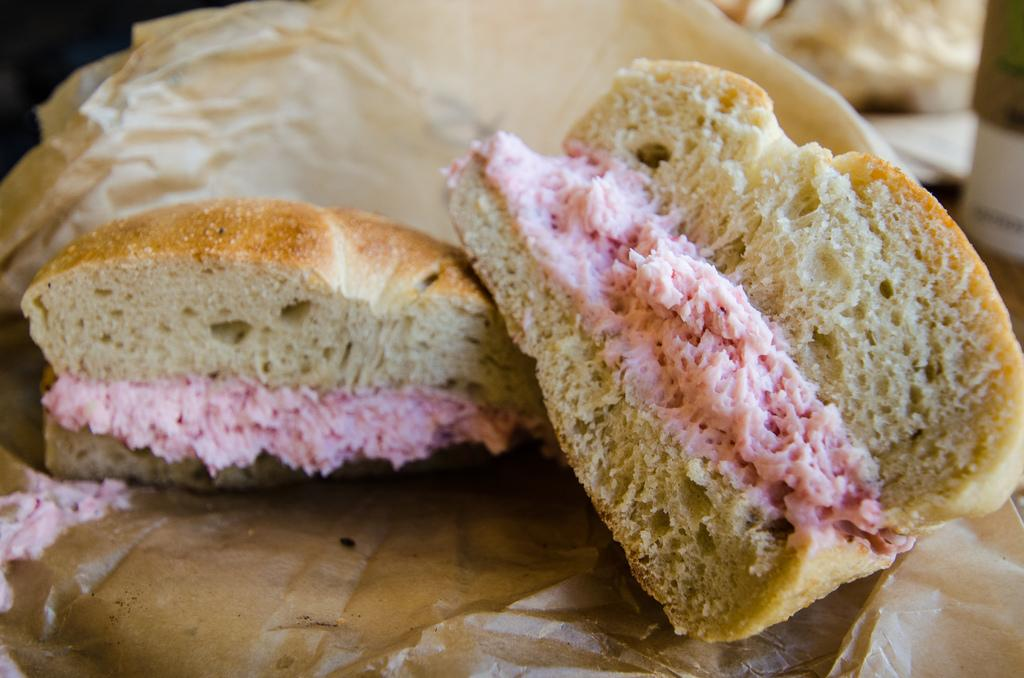What type of food is visible in the image? There are sandwich bites in the image. How many books are stacked on the tub in the image? There are no books or tubs present in the image; it only features sandwich bites. 